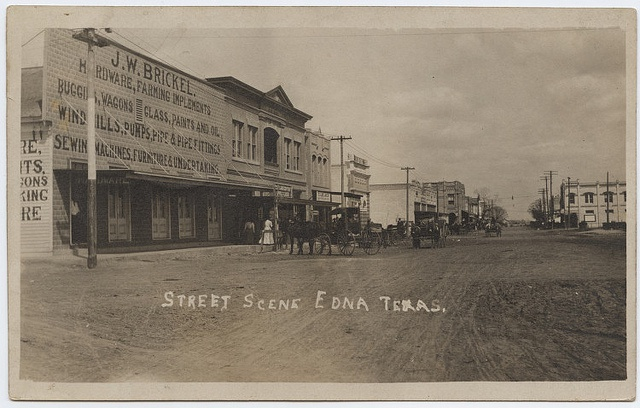Describe the objects in this image and their specific colors. I can see horse in lavender, black, and gray tones, people in lavender, black, and gray tones, people in lavender, black, and gray tones, people in lavender, darkgray, and gray tones, and people in lavender, black, and gray tones in this image. 